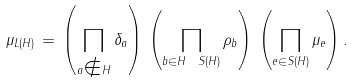<formula> <loc_0><loc_0><loc_500><loc_500>\mu _ { L ( H ) } \, = \, \left ( \prod _ { a \notin H } \delta _ { a } \right ) \, \left ( \prod _ { b \in H \ S ( H ) } \rho _ { b } \right ) \, \left ( \prod _ { e \in S ( H ) } \mu _ { e } \right ) .</formula> 